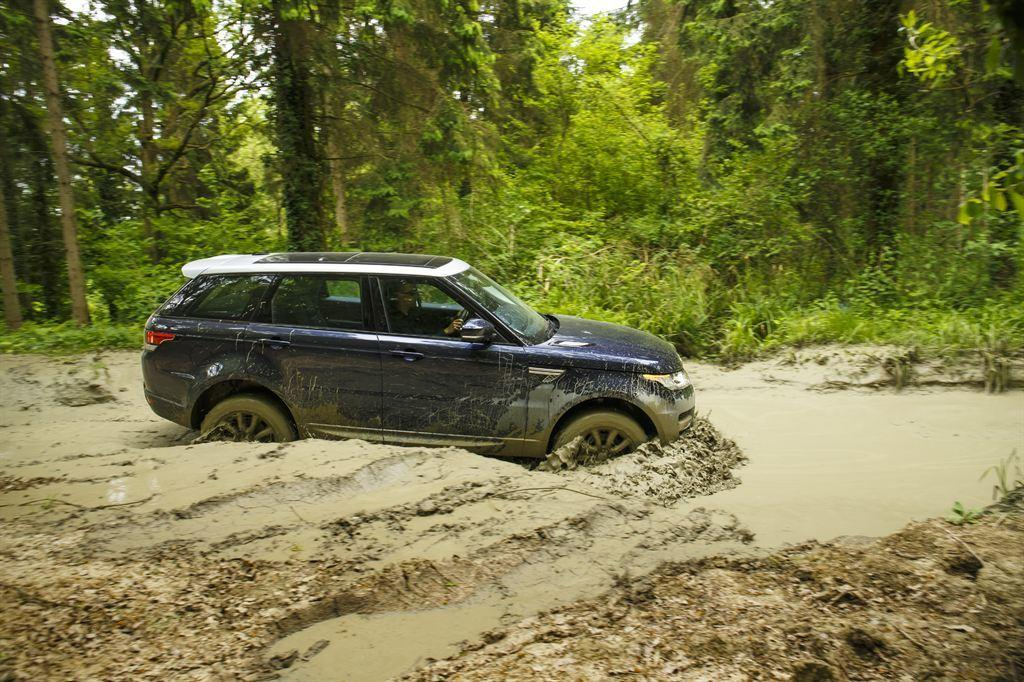What is the main subject of the image? There is a car in the image. Where is the car located? The car is parked on a muddy puddle. Is there anyone inside the car? Yes, there is a person sitting in the car. What can be seen in the background of the image? There are trees visible in the background of the image. What type of sail can be seen on the car in the image? There is no sail present on the car in the image. What is the car using to hold water in the image? The car is not using any basin to hold water in the image; it is parked on a muddy puddle. 